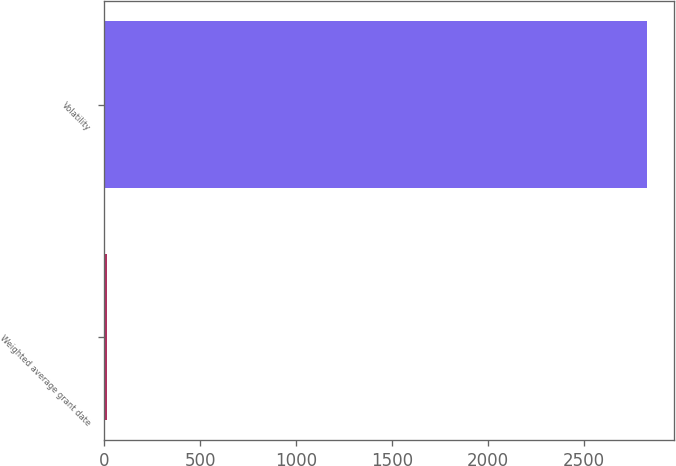<chart> <loc_0><loc_0><loc_500><loc_500><bar_chart><fcel>Weighted average grant date<fcel>Volatility<nl><fcel>12.75<fcel>2830<nl></chart> 